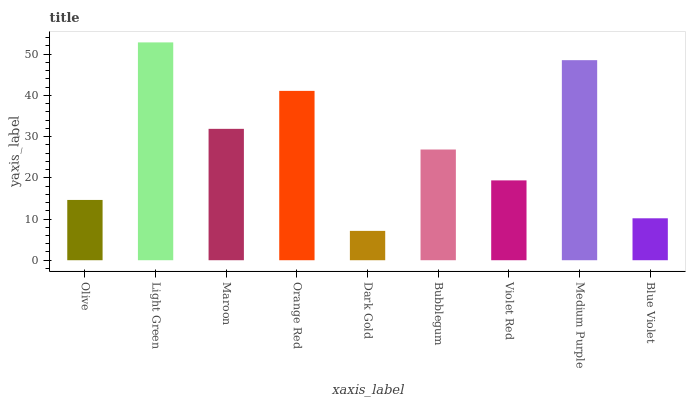Is Dark Gold the minimum?
Answer yes or no. Yes. Is Light Green the maximum?
Answer yes or no. Yes. Is Maroon the minimum?
Answer yes or no. No. Is Maroon the maximum?
Answer yes or no. No. Is Light Green greater than Maroon?
Answer yes or no. Yes. Is Maroon less than Light Green?
Answer yes or no. Yes. Is Maroon greater than Light Green?
Answer yes or no. No. Is Light Green less than Maroon?
Answer yes or no. No. Is Bubblegum the high median?
Answer yes or no. Yes. Is Bubblegum the low median?
Answer yes or no. Yes. Is Blue Violet the high median?
Answer yes or no. No. Is Maroon the low median?
Answer yes or no. No. 